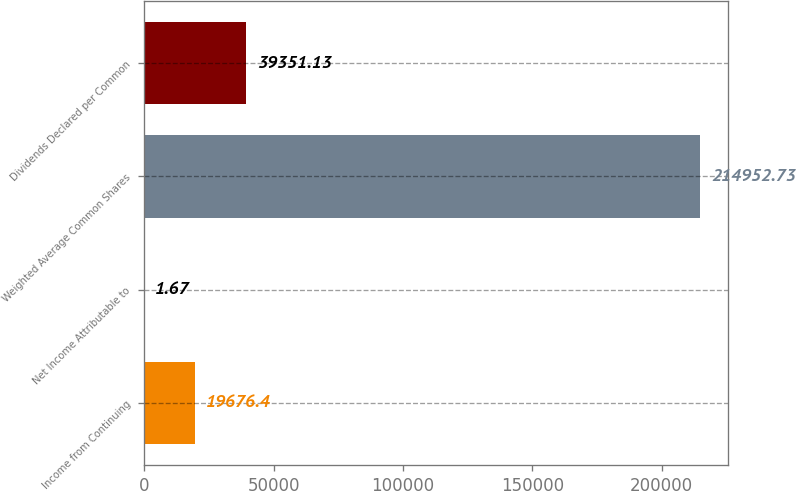Convert chart. <chart><loc_0><loc_0><loc_500><loc_500><bar_chart><fcel>Income from Continuing<fcel>Net Income Attributable to<fcel>Weighted Average Common Shares<fcel>Dividends Declared per Common<nl><fcel>19676.4<fcel>1.67<fcel>214953<fcel>39351.1<nl></chart> 